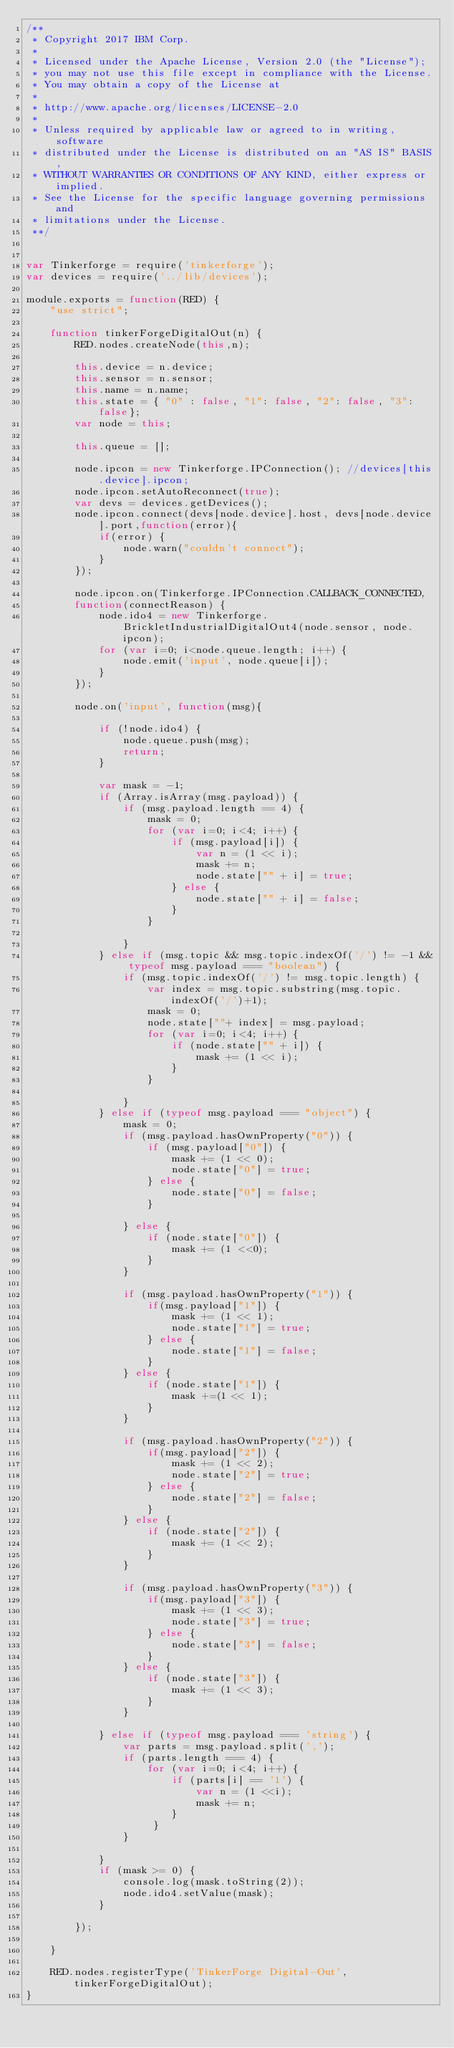Convert code to text. <code><loc_0><loc_0><loc_500><loc_500><_JavaScript_>/**
 * Copyright 2017 IBM Corp.
 *
 * Licensed under the Apache License, Version 2.0 (the "License");
 * you may not use this file except in compliance with the License.
 * You may obtain a copy of the License at
 *
 * http://www.apache.org/licenses/LICENSE-2.0
 *
 * Unless required by applicable law or agreed to in writing, software
 * distributed under the License is distributed on an "AS IS" BASIS,
 * WITHOUT WARRANTIES OR CONDITIONS OF ANY KIND, either express or implied.
 * See the License for the specific language governing permissions and
 * limitations under the License.
 **/


var Tinkerforge = require('tinkerforge');
var devices = require('../lib/devices');

module.exports = function(RED) {
    "use strict";

	function tinkerForgeDigitalOut(n) {
        RED.nodes.createNode(this,n);

        this.device = n.device;
        this.sensor = n.sensor;
        this.name = n.name;
        this.state = { "0" : false, "1": false, "2": false, "3": false};
        var node = this;

        this.queue = [];

        node.ipcon = new Tinkerforge.IPConnection(); //devices[this.device].ipcon;
        node.ipcon.setAutoReconnect(true);
        var devs = devices.getDevices();
        node.ipcon.connect(devs[node.device].host, devs[node.device].port,function(error){
            if(error) {
                node.warn("couldn't connect");
            }
        });

        node.ipcon.on(Tinkerforge.IPConnection.CALLBACK_CONNECTED,
        function(connectReason) {
            node.ido4 = new Tinkerforge.BrickletIndustrialDigitalOut4(node.sensor, node.ipcon);
            for (var i=0; i<node.queue.length; i++) {
                node.emit('input', node.queue[i]);
            }
        });

        node.on('input', function(msg){

            if (!node.ido4) {
                node.queue.push(msg);
                return;
            }

            var mask = -1;
            if (Array.isArray(msg.payload)) {
                if (msg.payload.length == 4) {
                    mask = 0;
                    for (var i=0; i<4; i++) {
                        if (msg.payload[i]) {
                            var n = (1 << i);
                            mask += n;
                            node.state["" + i] = true;
                        } else {
                            node.state["" + i] = false;
                        }
                    }

                }
            } else if (msg.topic && msg.topic.indexOf('/') != -1 && typeof msg.payload === "boolean") {
                if (msg.topic.indexOf('/') != msg.topic.length) {
                    var index = msg.topic.substring(msg.topic.indexOf('/')+1);
                    mask = 0;
                    node.state[""+ index] = msg.payload;
                    for (var i=0; i<4; i++) {
                        if (node.state["" + i]) {
                            mask += (1 << i);
                        }
                    }

                }
            } else if (typeof msg.payload === "object") {
                mask = 0;
                if (msg.payload.hasOwnProperty("0")) {
                    if (msg.payload["0"]) {
                        mask += (1 << 0);
                        node.state["0"] = true;
                    } else {
                        node.state["0"] = false;
                    }

                } else {
                    if (node.state["0"]) {
                        mask += (1 <<0);
                    }
                }

                if (msg.payload.hasOwnProperty("1")) {
                    if(msg.payload["1"]) {
                        mask += (1 << 1);
                        node.state["1"] = true;
                    } else {
                        node.state["1"] = false;
                    }
                } else {
                    if (node.state["1"]) {
                        mask +=(1 << 1);
                    }
                }

                if (msg.payload.hasOwnProperty("2")) {
                    if(msg.payload["2"]) {
                        mask += (1 << 2);
                        node.state["2"] = true;
                    } else {
                        node.state["2"] = false;
                    }
                } else {
                    if (node.state["2"]) {
                        mask += (1 << 2);
                    }
                }

                if (msg.payload.hasOwnProperty("3")) {
                    if(msg.payload["3"]) {
                        mask += (1 << 3);
                        node.state["3"] = true;
                    } else {
                        node.state["3"] = false;
                    }
                } else {
                    if (node.state["3"]) {
                        mask += (1 << 3);
                    }
                }

            } else if (typeof msg.payload === 'string') {
                var parts = msg.payload.split(',');
                if (parts.length === 4) {
                    for (var i=0; i<4; i++) {
                        if (parts[i] == '1') {
                            var n = (1 <<i);
                            mask += n;
                        }
                     }
                }

            }
            if (mask >= 0) {
                console.log(mask.toString(2));
                node.ido4.setValue(mask);
            }

        });

    }

    RED.nodes.registerType('TinkerForge Digital-Out', tinkerForgeDigitalOut);
}
</code> 